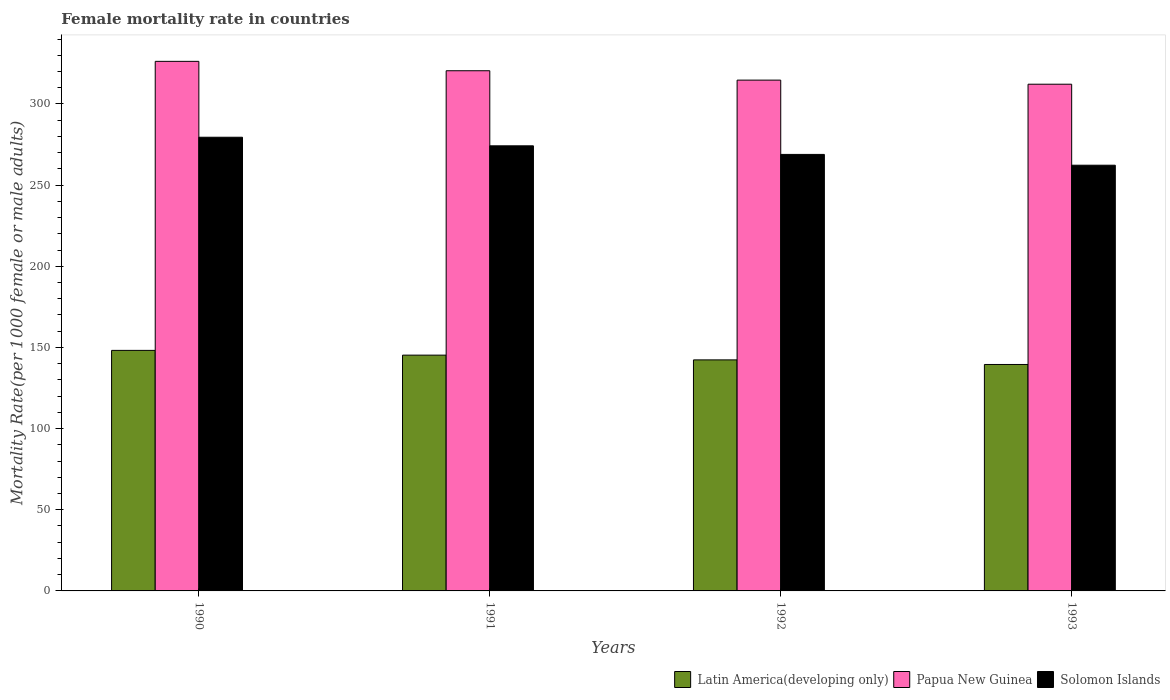How many different coloured bars are there?
Your answer should be very brief. 3. How many groups of bars are there?
Keep it short and to the point. 4. How many bars are there on the 1st tick from the right?
Your response must be concise. 3. What is the label of the 4th group of bars from the left?
Your answer should be compact. 1993. What is the female mortality rate in Latin America(developing only) in 1990?
Provide a succinct answer. 148.2. Across all years, what is the maximum female mortality rate in Solomon Islands?
Offer a very short reply. 279.52. Across all years, what is the minimum female mortality rate in Solomon Islands?
Give a very brief answer. 262.28. In which year was the female mortality rate in Latin America(developing only) maximum?
Your answer should be compact. 1990. In which year was the female mortality rate in Papua New Guinea minimum?
Your answer should be compact. 1993. What is the total female mortality rate in Latin America(developing only) in the graph?
Offer a very short reply. 575.33. What is the difference between the female mortality rate in Papua New Guinea in 1990 and that in 1992?
Your answer should be very brief. 11.56. What is the difference between the female mortality rate in Papua New Guinea in 1992 and the female mortality rate in Latin America(developing only) in 1993?
Your answer should be very brief. 175.19. What is the average female mortality rate in Papua New Guinea per year?
Your answer should be very brief. 318.41. In the year 1991, what is the difference between the female mortality rate in Latin America(developing only) and female mortality rate in Papua New Guinea?
Give a very brief answer. -175.21. What is the ratio of the female mortality rate in Latin America(developing only) in 1990 to that in 1993?
Your answer should be compact. 1.06. Is the female mortality rate in Solomon Islands in 1990 less than that in 1992?
Provide a short and direct response. No. What is the difference between the highest and the second highest female mortality rate in Solomon Islands?
Provide a short and direct response. 5.29. What is the difference between the highest and the lowest female mortality rate in Latin America(developing only)?
Your response must be concise. 8.68. Is the sum of the female mortality rate in Papua New Guinea in 1990 and 1993 greater than the maximum female mortality rate in Solomon Islands across all years?
Give a very brief answer. Yes. What does the 2nd bar from the left in 1992 represents?
Keep it short and to the point. Papua New Guinea. What does the 2nd bar from the right in 1990 represents?
Give a very brief answer. Papua New Guinea. Is it the case that in every year, the sum of the female mortality rate in Papua New Guinea and female mortality rate in Solomon Islands is greater than the female mortality rate in Latin America(developing only)?
Your answer should be very brief. Yes. Are the values on the major ticks of Y-axis written in scientific E-notation?
Provide a succinct answer. No. Does the graph contain grids?
Give a very brief answer. No. How are the legend labels stacked?
Offer a very short reply. Horizontal. What is the title of the graph?
Make the answer very short. Female mortality rate in countries. Does "Kazakhstan" appear as one of the legend labels in the graph?
Your answer should be very brief. No. What is the label or title of the Y-axis?
Your answer should be compact. Mortality Rate(per 1000 female or male adults). What is the Mortality Rate(per 1000 female or male adults) of Latin America(developing only) in 1990?
Make the answer very short. 148.2. What is the Mortality Rate(per 1000 female or male adults) of Papua New Guinea in 1990?
Provide a short and direct response. 326.27. What is the Mortality Rate(per 1000 female or male adults) in Solomon Islands in 1990?
Provide a short and direct response. 279.52. What is the Mortality Rate(per 1000 female or male adults) of Latin America(developing only) in 1991?
Your answer should be very brief. 145.27. What is the Mortality Rate(per 1000 female or male adults) in Papua New Guinea in 1991?
Keep it short and to the point. 320.49. What is the Mortality Rate(per 1000 female or male adults) in Solomon Islands in 1991?
Provide a short and direct response. 274.23. What is the Mortality Rate(per 1000 female or male adults) in Latin America(developing only) in 1992?
Keep it short and to the point. 142.35. What is the Mortality Rate(per 1000 female or male adults) of Papua New Guinea in 1992?
Offer a terse response. 314.7. What is the Mortality Rate(per 1000 female or male adults) in Solomon Islands in 1992?
Your answer should be compact. 268.94. What is the Mortality Rate(per 1000 female or male adults) in Latin America(developing only) in 1993?
Your answer should be compact. 139.52. What is the Mortality Rate(per 1000 female or male adults) of Papua New Guinea in 1993?
Give a very brief answer. 312.19. What is the Mortality Rate(per 1000 female or male adults) in Solomon Islands in 1993?
Make the answer very short. 262.28. Across all years, what is the maximum Mortality Rate(per 1000 female or male adults) of Latin America(developing only)?
Provide a succinct answer. 148.2. Across all years, what is the maximum Mortality Rate(per 1000 female or male adults) of Papua New Guinea?
Ensure brevity in your answer.  326.27. Across all years, what is the maximum Mortality Rate(per 1000 female or male adults) of Solomon Islands?
Your answer should be very brief. 279.52. Across all years, what is the minimum Mortality Rate(per 1000 female or male adults) in Latin America(developing only)?
Keep it short and to the point. 139.52. Across all years, what is the minimum Mortality Rate(per 1000 female or male adults) of Papua New Guinea?
Offer a very short reply. 312.19. Across all years, what is the minimum Mortality Rate(per 1000 female or male adults) in Solomon Islands?
Your answer should be compact. 262.28. What is the total Mortality Rate(per 1000 female or male adults) of Latin America(developing only) in the graph?
Your response must be concise. 575.33. What is the total Mortality Rate(per 1000 female or male adults) of Papua New Guinea in the graph?
Your answer should be compact. 1273.65. What is the total Mortality Rate(per 1000 female or male adults) of Solomon Islands in the graph?
Ensure brevity in your answer.  1084.96. What is the difference between the Mortality Rate(per 1000 female or male adults) in Latin America(developing only) in 1990 and that in 1991?
Give a very brief answer. 2.93. What is the difference between the Mortality Rate(per 1000 female or male adults) in Papua New Guinea in 1990 and that in 1991?
Your answer should be compact. 5.78. What is the difference between the Mortality Rate(per 1000 female or male adults) in Solomon Islands in 1990 and that in 1991?
Ensure brevity in your answer.  5.29. What is the difference between the Mortality Rate(per 1000 female or male adults) of Latin America(developing only) in 1990 and that in 1992?
Give a very brief answer. 5.85. What is the difference between the Mortality Rate(per 1000 female or male adults) of Papua New Guinea in 1990 and that in 1992?
Your answer should be very brief. 11.56. What is the difference between the Mortality Rate(per 1000 female or male adults) in Solomon Islands in 1990 and that in 1992?
Your answer should be compact. 10.58. What is the difference between the Mortality Rate(per 1000 female or male adults) of Latin America(developing only) in 1990 and that in 1993?
Make the answer very short. 8.68. What is the difference between the Mortality Rate(per 1000 female or male adults) of Papua New Guinea in 1990 and that in 1993?
Provide a short and direct response. 14.08. What is the difference between the Mortality Rate(per 1000 female or male adults) in Solomon Islands in 1990 and that in 1993?
Keep it short and to the point. 17.24. What is the difference between the Mortality Rate(per 1000 female or male adults) in Latin America(developing only) in 1991 and that in 1992?
Make the answer very short. 2.93. What is the difference between the Mortality Rate(per 1000 female or male adults) of Papua New Guinea in 1991 and that in 1992?
Give a very brief answer. 5.78. What is the difference between the Mortality Rate(per 1000 female or male adults) of Solomon Islands in 1991 and that in 1992?
Offer a very short reply. 5.29. What is the difference between the Mortality Rate(per 1000 female or male adults) in Latin America(developing only) in 1991 and that in 1993?
Your answer should be very brief. 5.76. What is the difference between the Mortality Rate(per 1000 female or male adults) of Papua New Guinea in 1991 and that in 1993?
Your response must be concise. 8.3. What is the difference between the Mortality Rate(per 1000 female or male adults) of Solomon Islands in 1991 and that in 1993?
Your answer should be very brief. 11.95. What is the difference between the Mortality Rate(per 1000 female or male adults) of Latin America(developing only) in 1992 and that in 1993?
Offer a very short reply. 2.83. What is the difference between the Mortality Rate(per 1000 female or male adults) in Papua New Guinea in 1992 and that in 1993?
Keep it short and to the point. 2.51. What is the difference between the Mortality Rate(per 1000 female or male adults) of Solomon Islands in 1992 and that in 1993?
Provide a short and direct response. 6.65. What is the difference between the Mortality Rate(per 1000 female or male adults) in Latin America(developing only) in 1990 and the Mortality Rate(per 1000 female or male adults) in Papua New Guinea in 1991?
Give a very brief answer. -172.29. What is the difference between the Mortality Rate(per 1000 female or male adults) in Latin America(developing only) in 1990 and the Mortality Rate(per 1000 female or male adults) in Solomon Islands in 1991?
Your answer should be very brief. -126.03. What is the difference between the Mortality Rate(per 1000 female or male adults) of Papua New Guinea in 1990 and the Mortality Rate(per 1000 female or male adults) of Solomon Islands in 1991?
Ensure brevity in your answer.  52.04. What is the difference between the Mortality Rate(per 1000 female or male adults) in Latin America(developing only) in 1990 and the Mortality Rate(per 1000 female or male adults) in Papua New Guinea in 1992?
Provide a short and direct response. -166.51. What is the difference between the Mortality Rate(per 1000 female or male adults) in Latin America(developing only) in 1990 and the Mortality Rate(per 1000 female or male adults) in Solomon Islands in 1992?
Make the answer very short. -120.74. What is the difference between the Mortality Rate(per 1000 female or male adults) of Papua New Guinea in 1990 and the Mortality Rate(per 1000 female or male adults) of Solomon Islands in 1992?
Your answer should be compact. 57.33. What is the difference between the Mortality Rate(per 1000 female or male adults) of Latin America(developing only) in 1990 and the Mortality Rate(per 1000 female or male adults) of Papua New Guinea in 1993?
Your answer should be compact. -163.99. What is the difference between the Mortality Rate(per 1000 female or male adults) in Latin America(developing only) in 1990 and the Mortality Rate(per 1000 female or male adults) in Solomon Islands in 1993?
Your response must be concise. -114.08. What is the difference between the Mortality Rate(per 1000 female or male adults) in Papua New Guinea in 1990 and the Mortality Rate(per 1000 female or male adults) in Solomon Islands in 1993?
Your answer should be compact. 63.99. What is the difference between the Mortality Rate(per 1000 female or male adults) in Latin America(developing only) in 1991 and the Mortality Rate(per 1000 female or male adults) in Papua New Guinea in 1992?
Ensure brevity in your answer.  -169.43. What is the difference between the Mortality Rate(per 1000 female or male adults) in Latin America(developing only) in 1991 and the Mortality Rate(per 1000 female or male adults) in Solomon Islands in 1992?
Your answer should be compact. -123.66. What is the difference between the Mortality Rate(per 1000 female or male adults) in Papua New Guinea in 1991 and the Mortality Rate(per 1000 female or male adults) in Solomon Islands in 1992?
Provide a short and direct response. 51.55. What is the difference between the Mortality Rate(per 1000 female or male adults) in Latin America(developing only) in 1991 and the Mortality Rate(per 1000 female or male adults) in Papua New Guinea in 1993?
Your answer should be very brief. -166.92. What is the difference between the Mortality Rate(per 1000 female or male adults) in Latin America(developing only) in 1991 and the Mortality Rate(per 1000 female or male adults) in Solomon Islands in 1993?
Provide a succinct answer. -117.01. What is the difference between the Mortality Rate(per 1000 female or male adults) of Papua New Guinea in 1991 and the Mortality Rate(per 1000 female or male adults) of Solomon Islands in 1993?
Your answer should be compact. 58.21. What is the difference between the Mortality Rate(per 1000 female or male adults) of Latin America(developing only) in 1992 and the Mortality Rate(per 1000 female or male adults) of Papua New Guinea in 1993?
Keep it short and to the point. -169.84. What is the difference between the Mortality Rate(per 1000 female or male adults) in Latin America(developing only) in 1992 and the Mortality Rate(per 1000 female or male adults) in Solomon Islands in 1993?
Your answer should be very brief. -119.93. What is the difference between the Mortality Rate(per 1000 female or male adults) of Papua New Guinea in 1992 and the Mortality Rate(per 1000 female or male adults) of Solomon Islands in 1993?
Your response must be concise. 52.42. What is the average Mortality Rate(per 1000 female or male adults) of Latin America(developing only) per year?
Your answer should be compact. 143.83. What is the average Mortality Rate(per 1000 female or male adults) in Papua New Guinea per year?
Your answer should be compact. 318.41. What is the average Mortality Rate(per 1000 female or male adults) in Solomon Islands per year?
Your answer should be compact. 271.24. In the year 1990, what is the difference between the Mortality Rate(per 1000 female or male adults) in Latin America(developing only) and Mortality Rate(per 1000 female or male adults) in Papua New Guinea?
Offer a terse response. -178.07. In the year 1990, what is the difference between the Mortality Rate(per 1000 female or male adults) of Latin America(developing only) and Mortality Rate(per 1000 female or male adults) of Solomon Islands?
Keep it short and to the point. -131.32. In the year 1990, what is the difference between the Mortality Rate(per 1000 female or male adults) in Papua New Guinea and Mortality Rate(per 1000 female or male adults) in Solomon Islands?
Provide a short and direct response. 46.75. In the year 1991, what is the difference between the Mortality Rate(per 1000 female or male adults) of Latin America(developing only) and Mortality Rate(per 1000 female or male adults) of Papua New Guinea?
Your response must be concise. -175.21. In the year 1991, what is the difference between the Mortality Rate(per 1000 female or male adults) in Latin America(developing only) and Mortality Rate(per 1000 female or male adults) in Solomon Islands?
Give a very brief answer. -128.95. In the year 1991, what is the difference between the Mortality Rate(per 1000 female or male adults) in Papua New Guinea and Mortality Rate(per 1000 female or male adults) in Solomon Islands?
Your answer should be very brief. 46.26. In the year 1992, what is the difference between the Mortality Rate(per 1000 female or male adults) of Latin America(developing only) and Mortality Rate(per 1000 female or male adults) of Papua New Guinea?
Ensure brevity in your answer.  -172.36. In the year 1992, what is the difference between the Mortality Rate(per 1000 female or male adults) of Latin America(developing only) and Mortality Rate(per 1000 female or male adults) of Solomon Islands?
Offer a terse response. -126.59. In the year 1992, what is the difference between the Mortality Rate(per 1000 female or male adults) in Papua New Guinea and Mortality Rate(per 1000 female or male adults) in Solomon Islands?
Your answer should be compact. 45.77. In the year 1993, what is the difference between the Mortality Rate(per 1000 female or male adults) in Latin America(developing only) and Mortality Rate(per 1000 female or male adults) in Papua New Guinea?
Your answer should be compact. -172.68. In the year 1993, what is the difference between the Mortality Rate(per 1000 female or male adults) in Latin America(developing only) and Mortality Rate(per 1000 female or male adults) in Solomon Islands?
Ensure brevity in your answer.  -122.77. In the year 1993, what is the difference between the Mortality Rate(per 1000 female or male adults) of Papua New Guinea and Mortality Rate(per 1000 female or male adults) of Solomon Islands?
Give a very brief answer. 49.91. What is the ratio of the Mortality Rate(per 1000 female or male adults) in Latin America(developing only) in 1990 to that in 1991?
Your response must be concise. 1.02. What is the ratio of the Mortality Rate(per 1000 female or male adults) in Solomon Islands in 1990 to that in 1991?
Provide a short and direct response. 1.02. What is the ratio of the Mortality Rate(per 1000 female or male adults) in Latin America(developing only) in 1990 to that in 1992?
Offer a very short reply. 1.04. What is the ratio of the Mortality Rate(per 1000 female or male adults) in Papua New Guinea in 1990 to that in 1992?
Provide a short and direct response. 1.04. What is the ratio of the Mortality Rate(per 1000 female or male adults) of Solomon Islands in 1990 to that in 1992?
Give a very brief answer. 1.04. What is the ratio of the Mortality Rate(per 1000 female or male adults) in Latin America(developing only) in 1990 to that in 1993?
Offer a terse response. 1.06. What is the ratio of the Mortality Rate(per 1000 female or male adults) in Papua New Guinea in 1990 to that in 1993?
Your response must be concise. 1.05. What is the ratio of the Mortality Rate(per 1000 female or male adults) of Solomon Islands in 1990 to that in 1993?
Your answer should be very brief. 1.07. What is the ratio of the Mortality Rate(per 1000 female or male adults) of Latin America(developing only) in 1991 to that in 1992?
Ensure brevity in your answer.  1.02. What is the ratio of the Mortality Rate(per 1000 female or male adults) in Papua New Guinea in 1991 to that in 1992?
Offer a very short reply. 1.02. What is the ratio of the Mortality Rate(per 1000 female or male adults) in Solomon Islands in 1991 to that in 1992?
Provide a succinct answer. 1.02. What is the ratio of the Mortality Rate(per 1000 female or male adults) of Latin America(developing only) in 1991 to that in 1993?
Your answer should be very brief. 1.04. What is the ratio of the Mortality Rate(per 1000 female or male adults) in Papua New Guinea in 1991 to that in 1993?
Make the answer very short. 1.03. What is the ratio of the Mortality Rate(per 1000 female or male adults) of Solomon Islands in 1991 to that in 1993?
Keep it short and to the point. 1.05. What is the ratio of the Mortality Rate(per 1000 female or male adults) in Latin America(developing only) in 1992 to that in 1993?
Offer a terse response. 1.02. What is the ratio of the Mortality Rate(per 1000 female or male adults) in Solomon Islands in 1992 to that in 1993?
Make the answer very short. 1.03. What is the difference between the highest and the second highest Mortality Rate(per 1000 female or male adults) of Latin America(developing only)?
Provide a short and direct response. 2.93. What is the difference between the highest and the second highest Mortality Rate(per 1000 female or male adults) in Papua New Guinea?
Keep it short and to the point. 5.78. What is the difference between the highest and the second highest Mortality Rate(per 1000 female or male adults) of Solomon Islands?
Your answer should be compact. 5.29. What is the difference between the highest and the lowest Mortality Rate(per 1000 female or male adults) of Latin America(developing only)?
Give a very brief answer. 8.68. What is the difference between the highest and the lowest Mortality Rate(per 1000 female or male adults) in Papua New Guinea?
Give a very brief answer. 14.08. What is the difference between the highest and the lowest Mortality Rate(per 1000 female or male adults) in Solomon Islands?
Your answer should be very brief. 17.24. 